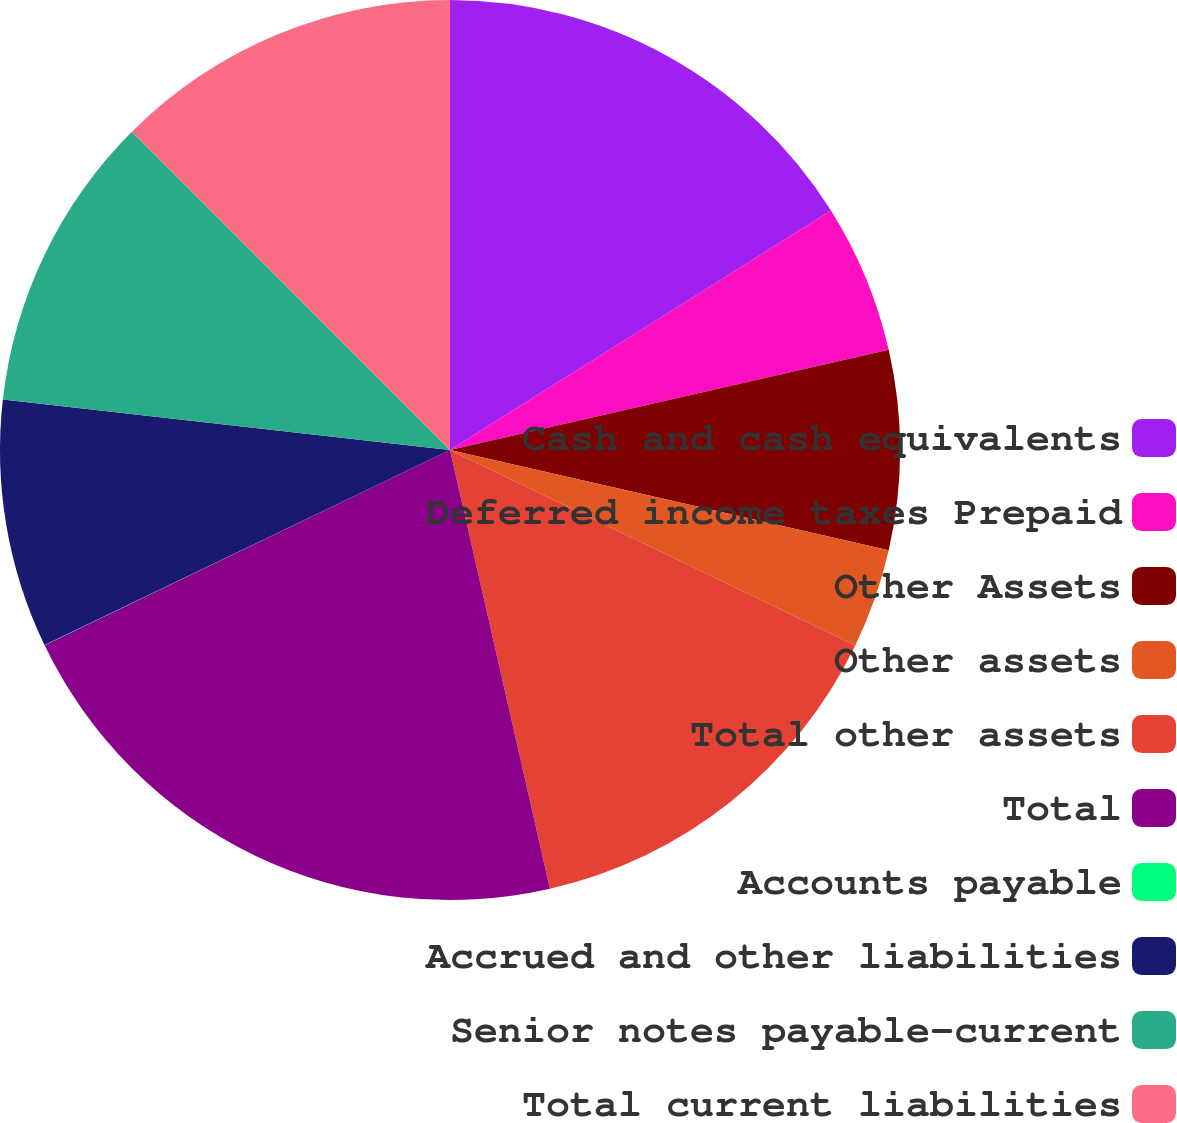<chart> <loc_0><loc_0><loc_500><loc_500><pie_chart><fcel>Cash and cash equivalents<fcel>Deferred income taxes Prepaid<fcel>Other Assets<fcel>Other assets<fcel>Total other assets<fcel>Total<fcel>Accounts payable<fcel>Accrued and other liabilities<fcel>Senior notes payable-current<fcel>Total current liabilities<nl><fcel>16.07%<fcel>5.36%<fcel>7.15%<fcel>3.58%<fcel>14.28%<fcel>21.42%<fcel>0.01%<fcel>8.93%<fcel>10.71%<fcel>12.5%<nl></chart> 